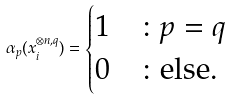<formula> <loc_0><loc_0><loc_500><loc_500>\alpha _ { p } ( x _ { i } ^ { \otimes n , q } ) = \begin{cases} 1 & \colon p = q \\ 0 & \colon \text {else.} \\ \end{cases}</formula> 